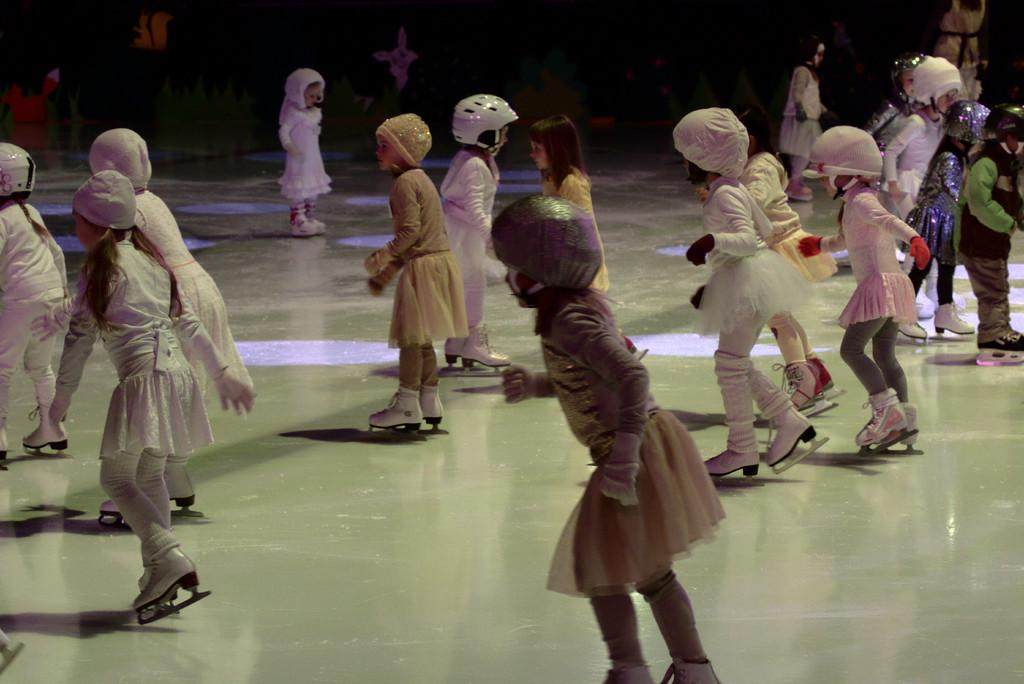What is happening in the image involving the group of kids? The kids are skating on the floor in the image. Are the kids wearing any protective gear while skating? Yes, some of the kids are wearing helmets. What else can be seen on the heads of the kids in the image? Some of the kids are wearing caps. How would you describe the background of the image? The background of the image has a dark view. What type of club is being used by the kids in the image? There is no club present in the image; the kids are skating on the floor. Is there any smoke visible in the image? No, there is no smoke visible in the image. 